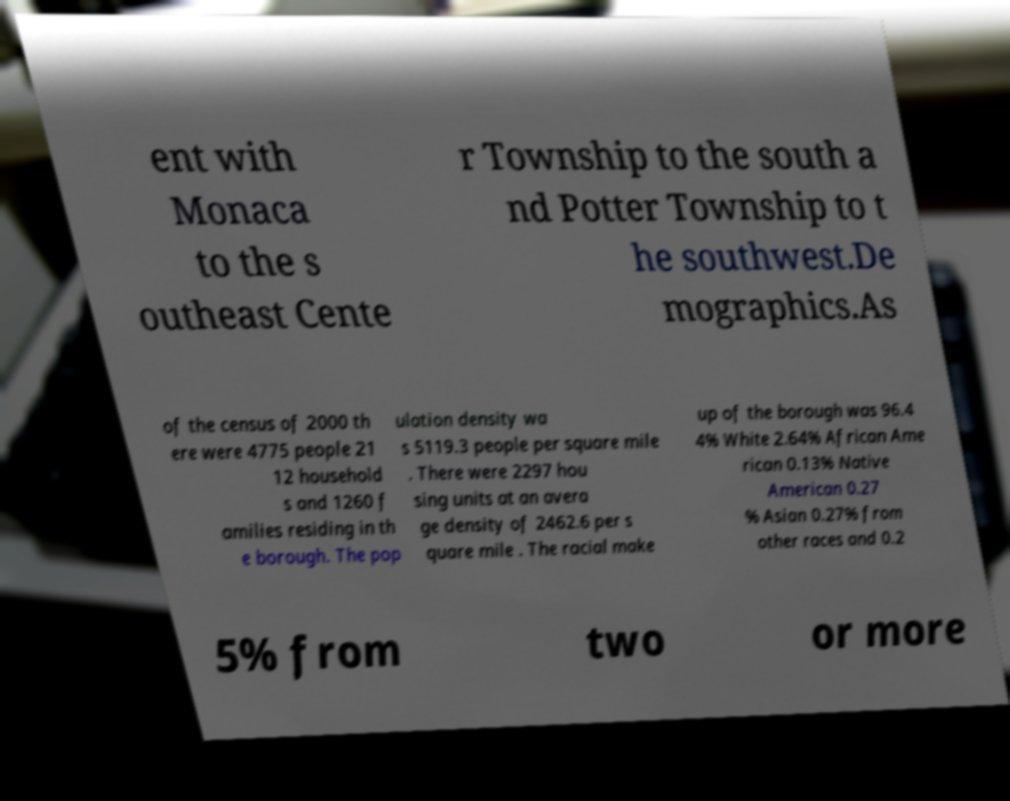There's text embedded in this image that I need extracted. Can you transcribe it verbatim? ent with Monaca to the s outheast Cente r Township to the south a nd Potter Township to t he southwest.De mographics.As of the census of 2000 th ere were 4775 people 21 12 household s and 1260 f amilies residing in th e borough. The pop ulation density wa s 5119.3 people per square mile . There were 2297 hou sing units at an avera ge density of 2462.6 per s quare mile . The racial make up of the borough was 96.4 4% White 2.64% African Ame rican 0.13% Native American 0.27 % Asian 0.27% from other races and 0.2 5% from two or more 